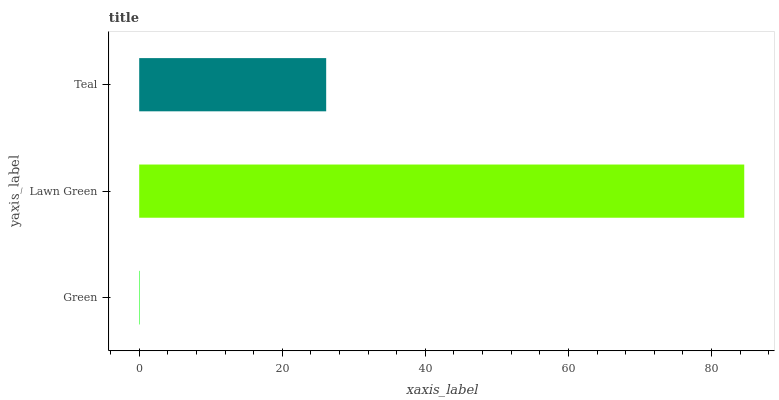Is Green the minimum?
Answer yes or no. Yes. Is Lawn Green the maximum?
Answer yes or no. Yes. Is Teal the minimum?
Answer yes or no. No. Is Teal the maximum?
Answer yes or no. No. Is Lawn Green greater than Teal?
Answer yes or no. Yes. Is Teal less than Lawn Green?
Answer yes or no. Yes. Is Teal greater than Lawn Green?
Answer yes or no. No. Is Lawn Green less than Teal?
Answer yes or no. No. Is Teal the high median?
Answer yes or no. Yes. Is Teal the low median?
Answer yes or no. Yes. Is Green the high median?
Answer yes or no. No. Is Green the low median?
Answer yes or no. No. 